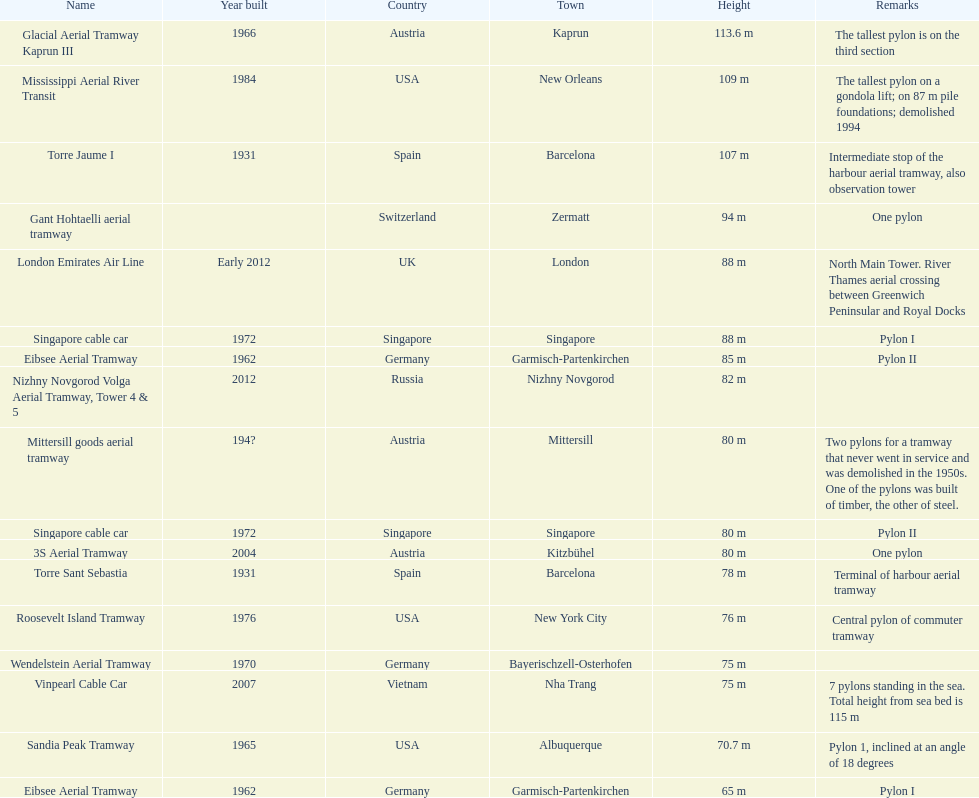How many towers are in austria? 3. 